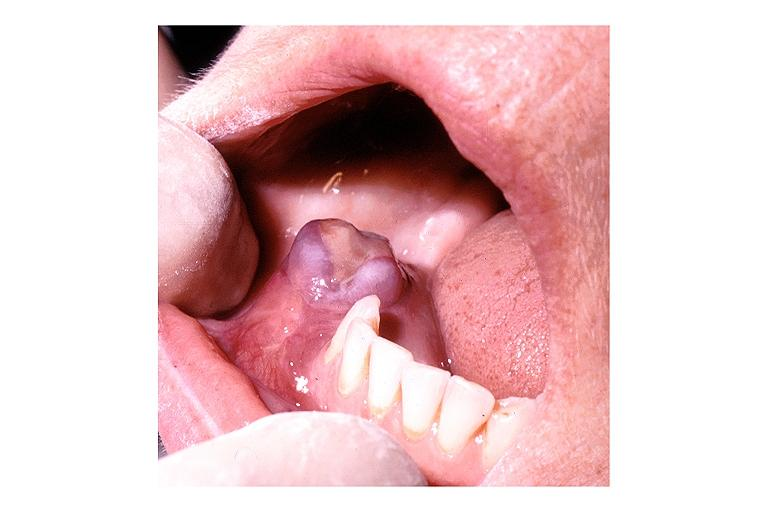what is present?
Answer the question using a single word or phrase. Oral 